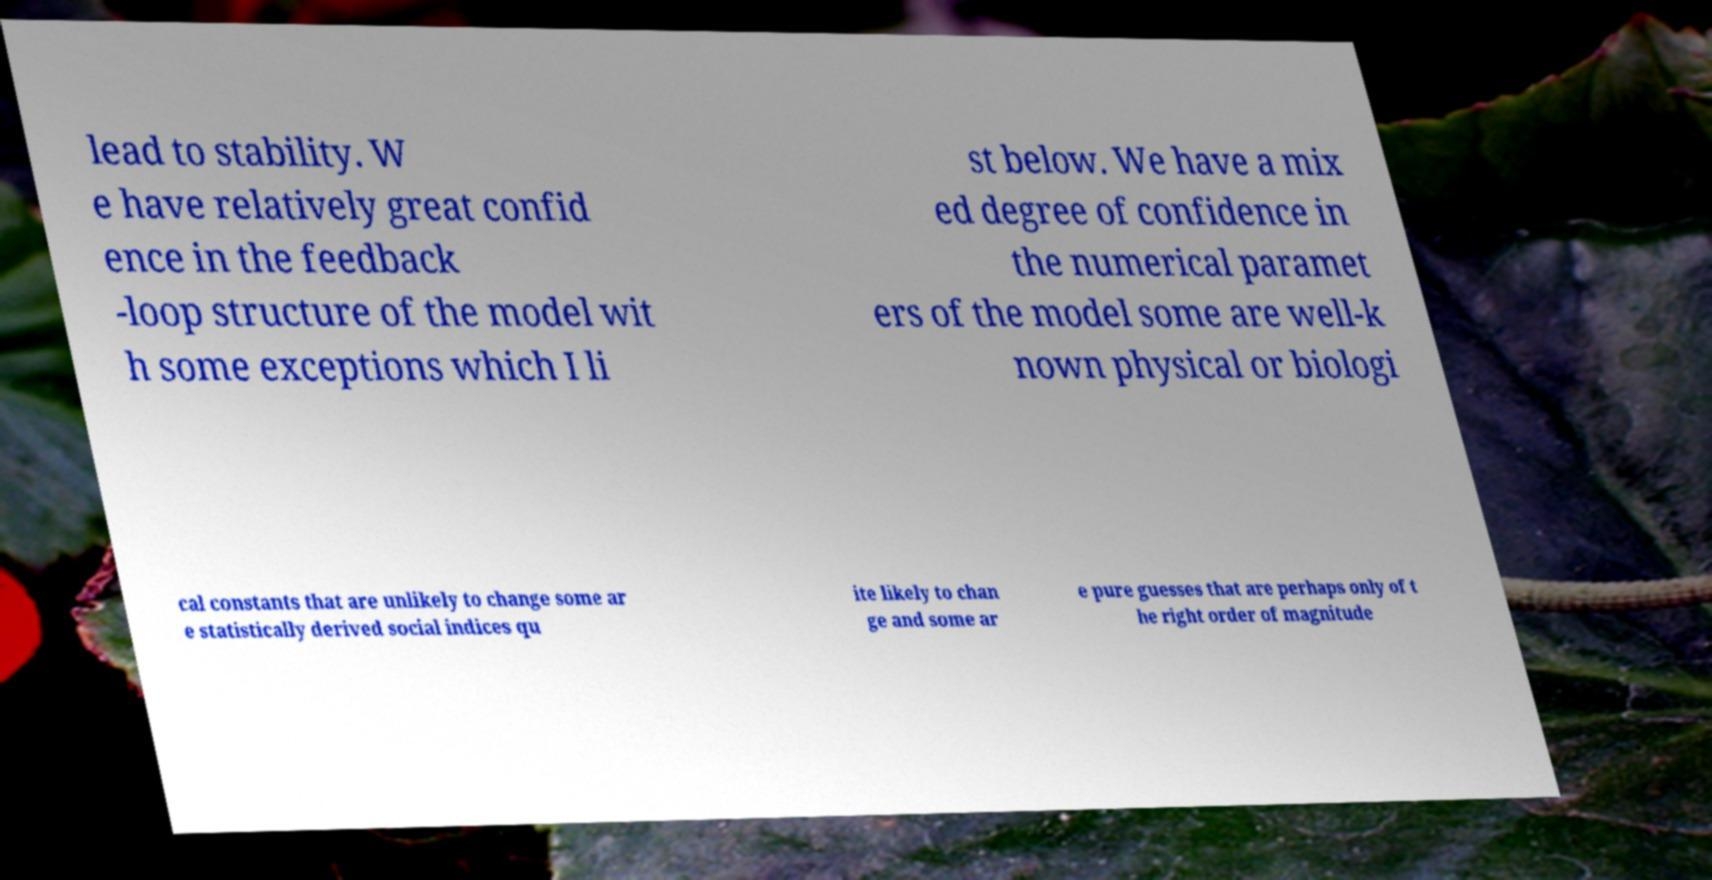Can you read and provide the text displayed in the image?This photo seems to have some interesting text. Can you extract and type it out for me? lead to stability. W e have relatively great confid ence in the feedback -loop structure of the model wit h some exceptions which I li st below. We have a mix ed degree of confidence in the numerical paramet ers of the model some are well-k nown physical or biologi cal constants that are unlikely to change some ar e statistically derived social indices qu ite likely to chan ge and some ar e pure guesses that are perhaps only of t he right order of magnitude 